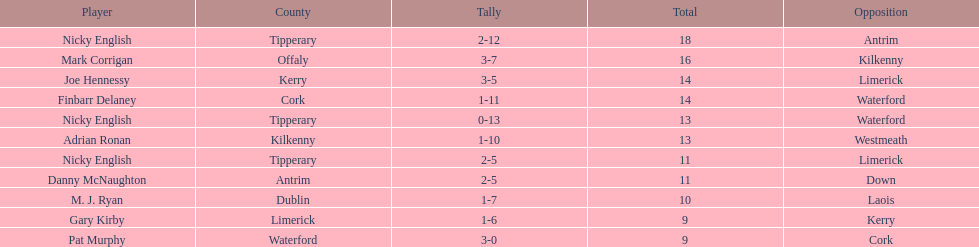Who was the top ranked player in a single game? Nicky English. 